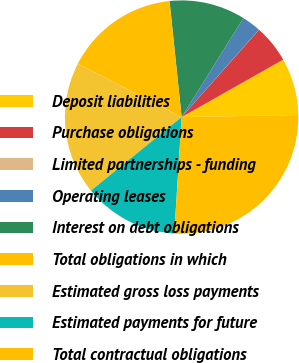Convert chart to OTSL. <chart><loc_0><loc_0><loc_500><loc_500><pie_chart><fcel>Deposit liabilities<fcel>Purchase obligations<fcel>Limited partnerships - funding<fcel>Operating leases<fcel>Interest on debt obligations<fcel>Total obligations in which<fcel>Estimated gross loss payments<fcel>Estimated payments for future<fcel>Total contractual obligations<nl><fcel>7.9%<fcel>5.27%<fcel>0.02%<fcel>2.64%<fcel>10.53%<fcel>15.78%<fcel>18.41%<fcel>13.15%<fcel>26.29%<nl></chart> 